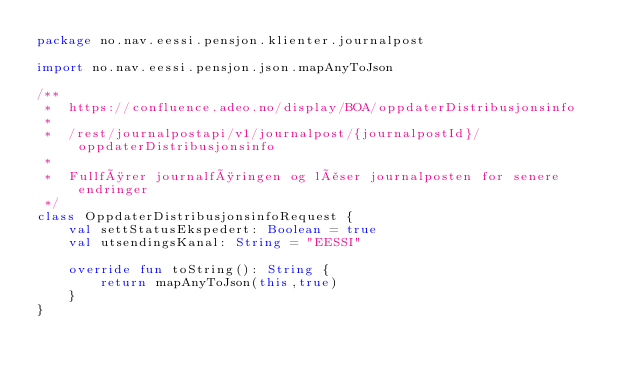<code> <loc_0><loc_0><loc_500><loc_500><_Kotlin_>package no.nav.eessi.pensjon.klienter.journalpost

import no.nav.eessi.pensjon.json.mapAnyToJson

/**
 *  https://confluence.adeo.no/display/BOA/oppdaterDistribusjonsinfo
 *
 *  /rest/journalpostapi/v1/journalpost/{journalpostId}/oppdaterDistribusjonsinfo
 *
 *  Fullfører journalføringen og låser journalposten for senere endringer
 */
class OppdaterDistribusjonsinfoRequest {
    val settStatusEkspedert: Boolean = true
    val utsendingsKanal: String = "EESSI"

    override fun toString(): String {
        return mapAnyToJson(this,true)
    }
}
</code> 